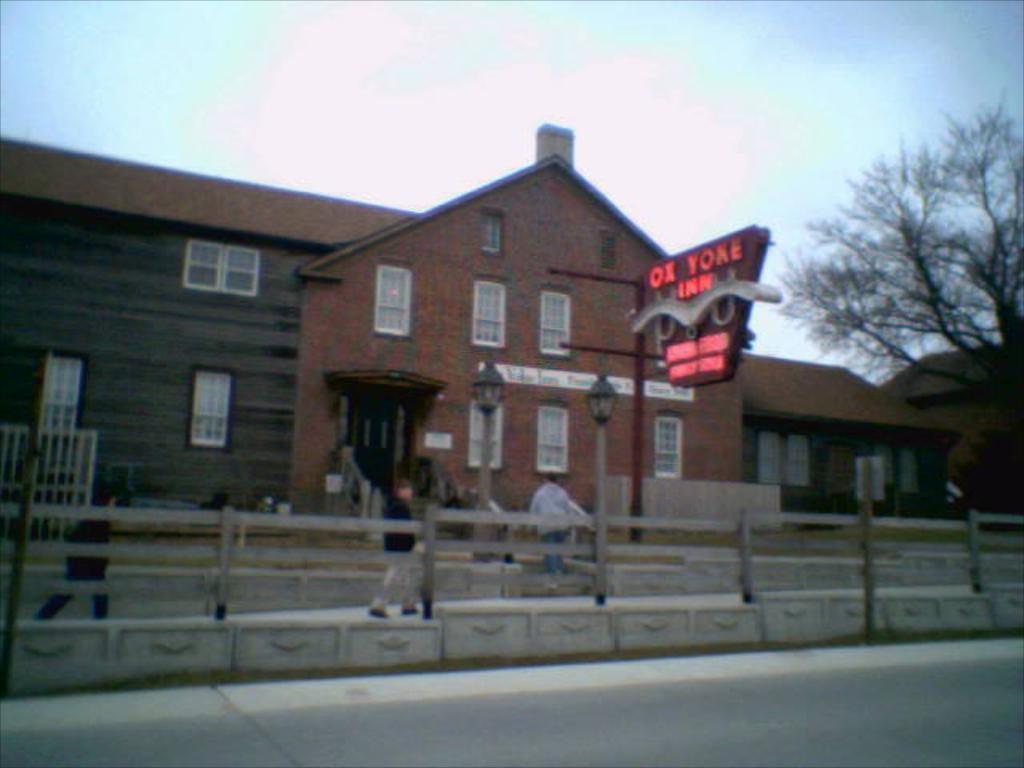What type of structure is present in the image? There is a building in the image. What feature can be seen on the building? The building has windows. What other objects are visible in the image? There are light poles, a board, fencing, trees, and people in the image. What is visible in the background of the image? The sky is visible in the image. What type of seat is visible in the image? There is no seat present in the image. What color is the coat worn by the person in the image? There is no coat visible in the image; people are present, but no specific clothing items are mentioned. 